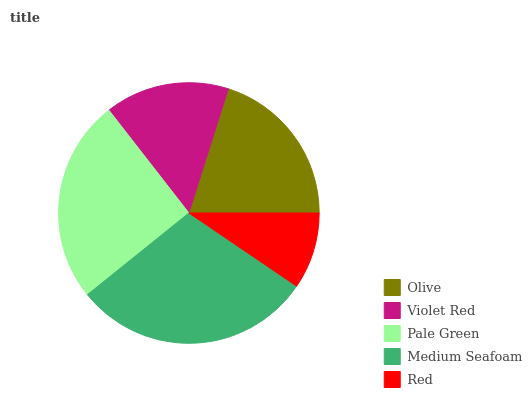Is Red the minimum?
Answer yes or no. Yes. Is Medium Seafoam the maximum?
Answer yes or no. Yes. Is Violet Red the minimum?
Answer yes or no. No. Is Violet Red the maximum?
Answer yes or no. No. Is Olive greater than Violet Red?
Answer yes or no. Yes. Is Violet Red less than Olive?
Answer yes or no. Yes. Is Violet Red greater than Olive?
Answer yes or no. No. Is Olive less than Violet Red?
Answer yes or no. No. Is Olive the high median?
Answer yes or no. Yes. Is Olive the low median?
Answer yes or no. Yes. Is Pale Green the high median?
Answer yes or no. No. Is Red the low median?
Answer yes or no. No. 